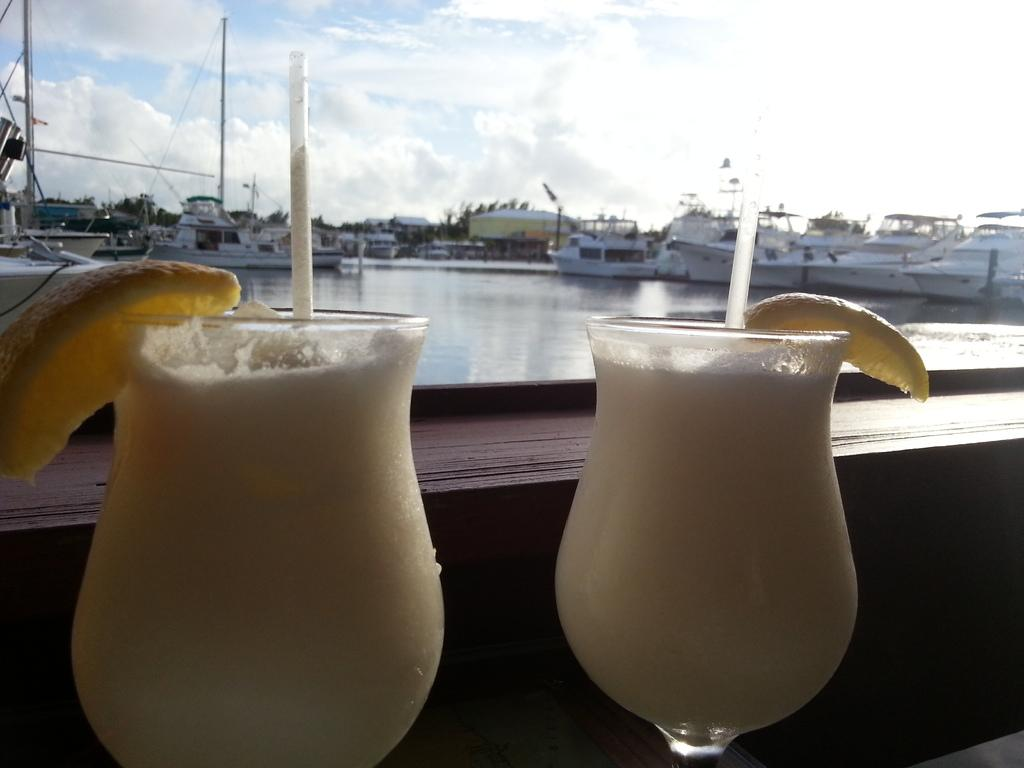How many juice glasses are in the image? There are two juice glasses in the image. What is on top of the juice glasses? The juice glasses have lemon slices on them. What can be seen in the water in the image? There are boats visible in the water in the image. What is the condition of the sky in the image? The sky is cloudy in the image. What type of crime is being committed in the image? There is no indication of any crime being committed in the image. How many tomatoes are floating in the water in the image? There are no tomatoes visible in the water in the image. 